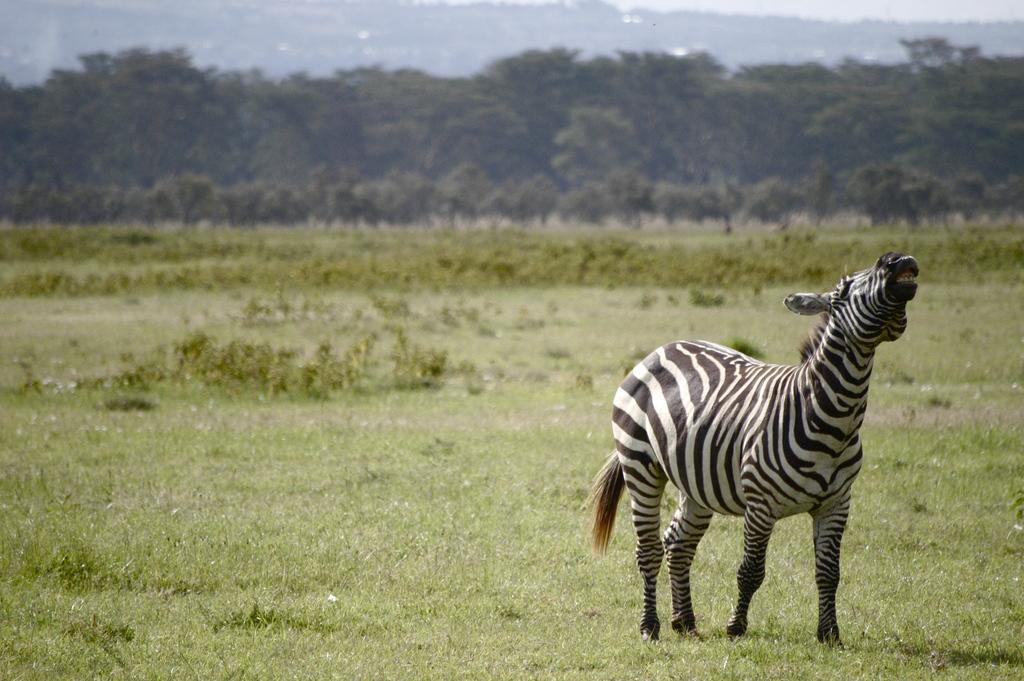Please provide a concise description of this image. In this image we can see a bird on the surface. In the background, we can see water. 